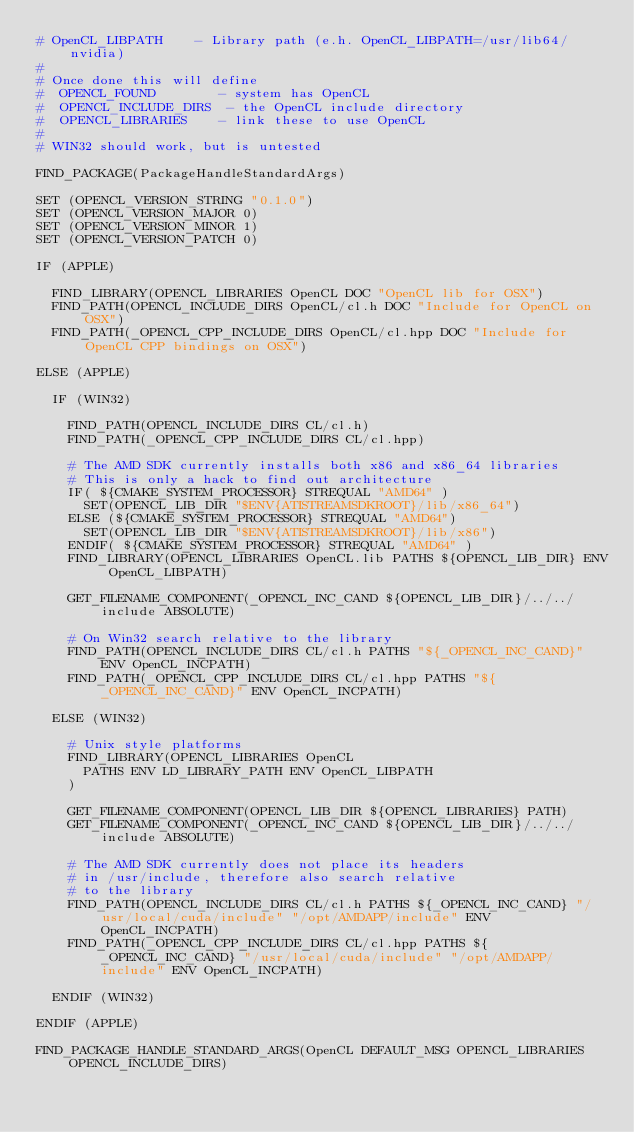<code> <loc_0><loc_0><loc_500><loc_500><_CMake_># OpenCL_LIBPATH    - Library path (e.h. OpenCL_LIBPATH=/usr/lib64/nvidia)
#
# Once done this will define
#  OPENCL_FOUND        - system has OpenCL
#  OPENCL_INCLUDE_DIRS  - the OpenCL include directory
#  OPENCL_LIBRARIES    - link these to use OpenCL
#
# WIN32 should work, but is untested

FIND_PACKAGE(PackageHandleStandardArgs)

SET (OPENCL_VERSION_STRING "0.1.0")
SET (OPENCL_VERSION_MAJOR 0)
SET (OPENCL_VERSION_MINOR 1)
SET (OPENCL_VERSION_PATCH 0)

IF (APPLE)

	FIND_LIBRARY(OPENCL_LIBRARIES OpenCL DOC "OpenCL lib for OSX")
	FIND_PATH(OPENCL_INCLUDE_DIRS OpenCL/cl.h DOC "Include for OpenCL on OSX")
	FIND_PATH(_OPENCL_CPP_INCLUDE_DIRS OpenCL/cl.hpp DOC "Include for OpenCL CPP bindings on OSX")

ELSE (APPLE)

	IF (WIN32)

		FIND_PATH(OPENCL_INCLUDE_DIRS CL/cl.h)
		FIND_PATH(_OPENCL_CPP_INCLUDE_DIRS CL/cl.hpp)

		# The AMD SDK currently installs both x86 and x86_64 libraries
		# This is only a hack to find out architecture
		IF( ${CMAKE_SYSTEM_PROCESSOR} STREQUAL "AMD64" )
			SET(OPENCL_LIB_DIR "$ENV{ATISTREAMSDKROOT}/lib/x86_64")
		ELSE (${CMAKE_SYSTEM_PROCESSOR} STREQUAL "AMD64")
			SET(OPENCL_LIB_DIR "$ENV{ATISTREAMSDKROOT}/lib/x86")
		ENDIF( ${CMAKE_SYSTEM_PROCESSOR} STREQUAL "AMD64" )
		FIND_LIBRARY(OPENCL_LIBRARIES OpenCL.lib PATHS ${OPENCL_LIB_DIR} ENV OpenCL_LIBPATH)

		GET_FILENAME_COMPONENT(_OPENCL_INC_CAND ${OPENCL_LIB_DIR}/../../include ABSOLUTE)

		# On Win32 search relative to the library
		FIND_PATH(OPENCL_INCLUDE_DIRS CL/cl.h PATHS "${_OPENCL_INC_CAND}" ENV OpenCL_INCPATH)
		FIND_PATH(_OPENCL_CPP_INCLUDE_DIRS CL/cl.hpp PATHS "${_OPENCL_INC_CAND}" ENV OpenCL_INCPATH)

	ELSE (WIN32)

		# Unix style platforms
		FIND_LIBRARY(OPENCL_LIBRARIES OpenCL
			PATHS ENV LD_LIBRARY_PATH ENV OpenCL_LIBPATH
		)

		GET_FILENAME_COMPONENT(OPENCL_LIB_DIR ${OPENCL_LIBRARIES} PATH)
		GET_FILENAME_COMPONENT(_OPENCL_INC_CAND ${OPENCL_LIB_DIR}/../../include ABSOLUTE)

		# The AMD SDK currently does not place its headers
		# in /usr/include, therefore also search relative
		# to the library
		FIND_PATH(OPENCL_INCLUDE_DIRS CL/cl.h PATHS ${_OPENCL_INC_CAND} "/usr/local/cuda/include" "/opt/AMDAPP/include" ENV OpenCL_INCPATH)
		FIND_PATH(_OPENCL_CPP_INCLUDE_DIRS CL/cl.hpp PATHS ${_OPENCL_INC_CAND} "/usr/local/cuda/include" "/opt/AMDAPP/include" ENV OpenCL_INCPATH)

	ENDIF (WIN32)

ENDIF (APPLE)

FIND_PACKAGE_HANDLE_STANDARD_ARGS(OpenCL DEFAULT_MSG OPENCL_LIBRARIES OPENCL_INCLUDE_DIRS)
</code> 